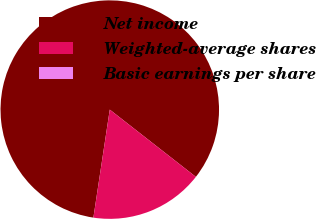<chart> <loc_0><loc_0><loc_500><loc_500><pie_chart><fcel>Net income<fcel>Weighted-average shares<fcel>Basic earnings per share<nl><fcel>83.16%<fcel>16.84%<fcel>0.0%<nl></chart> 